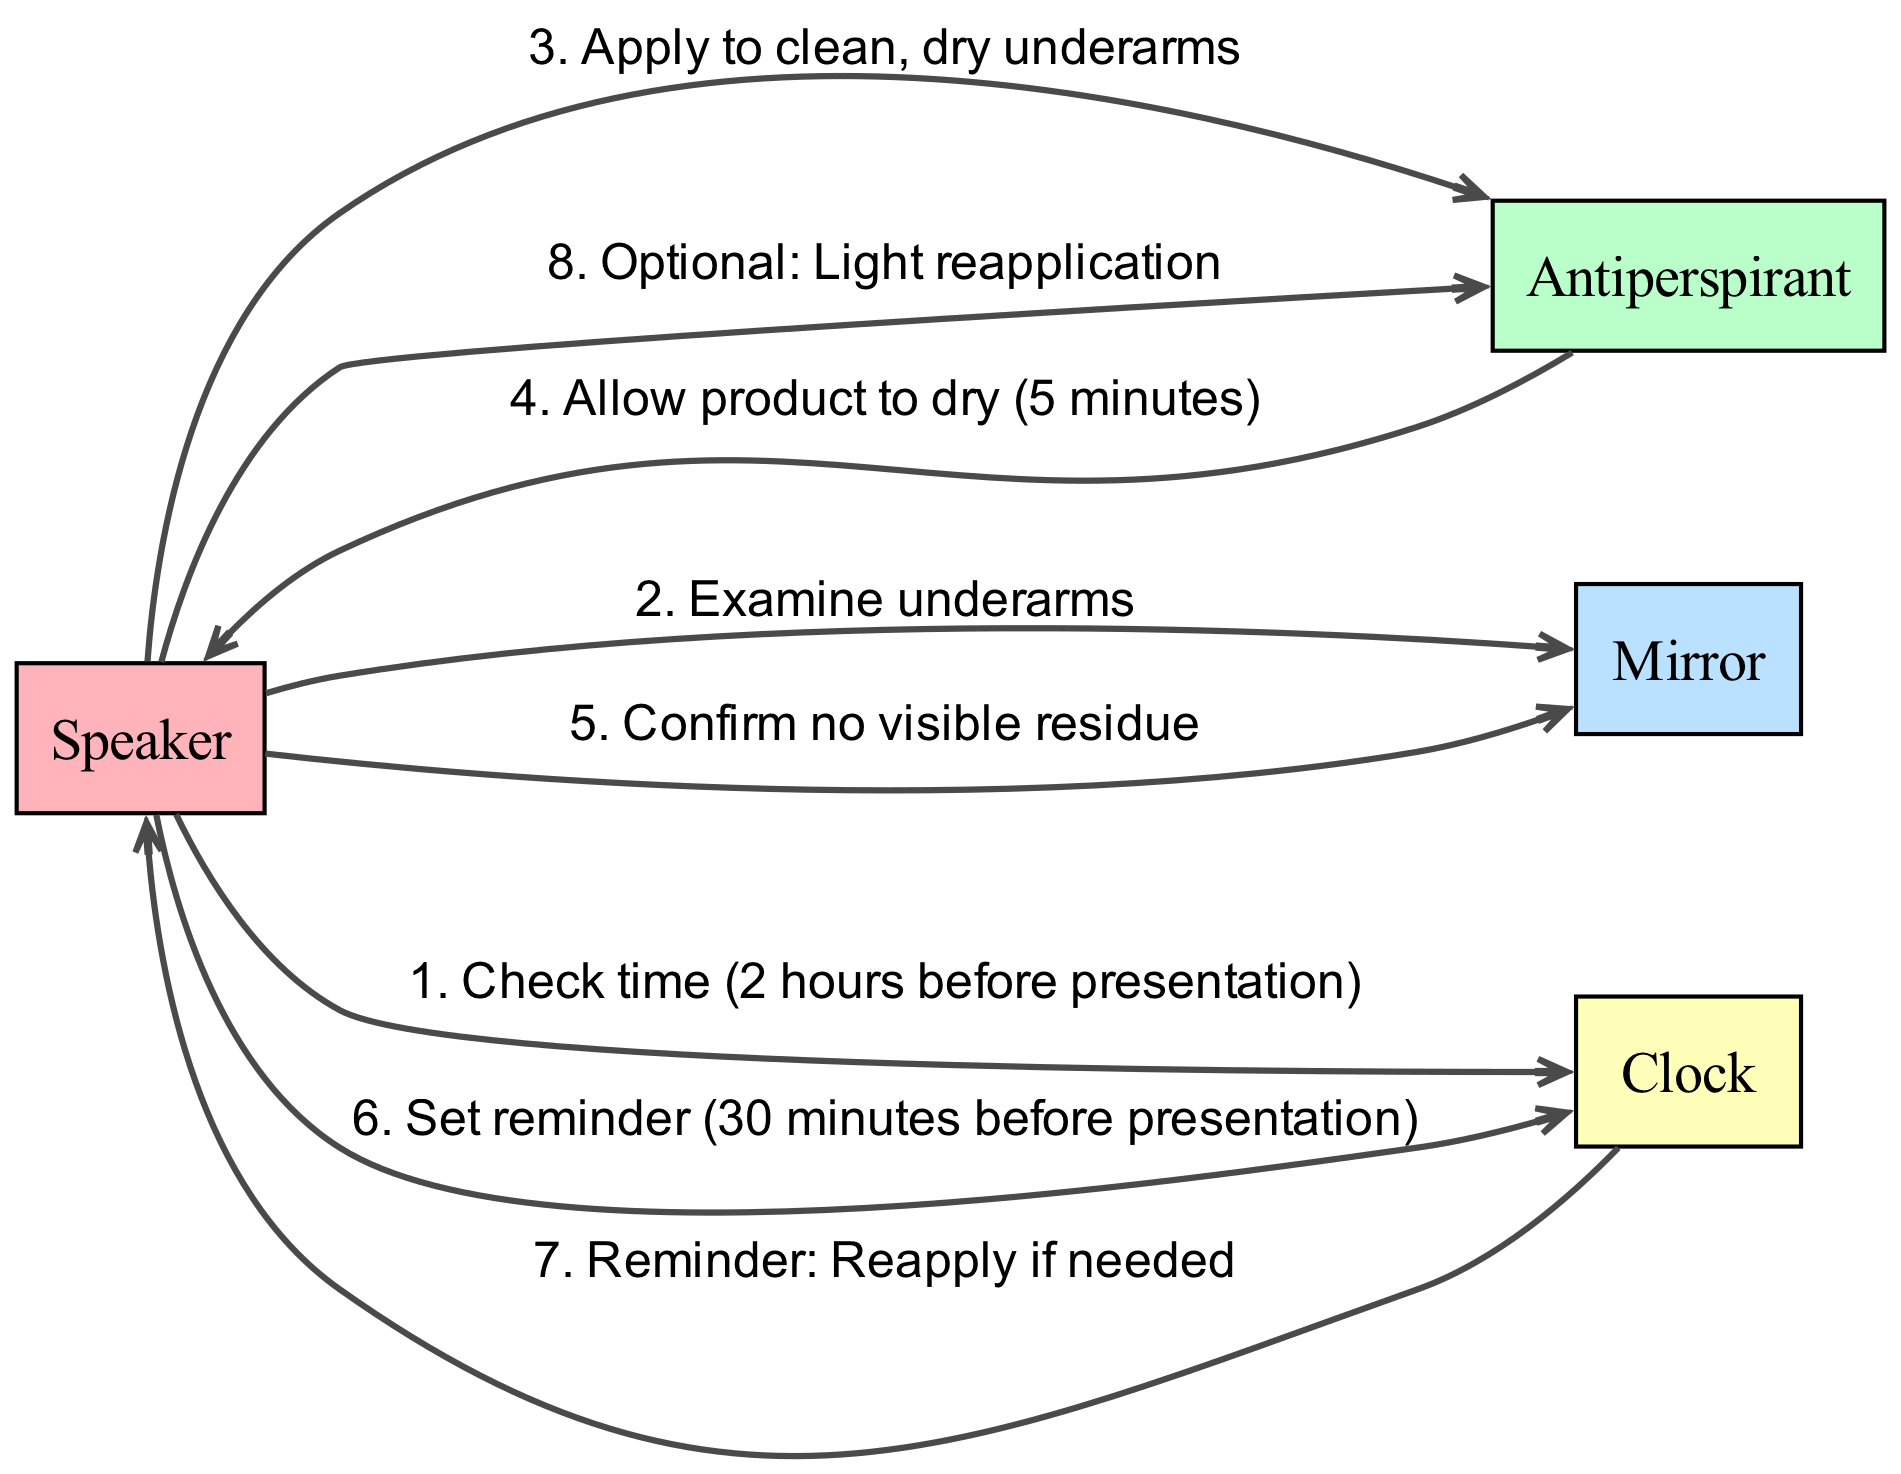What is the first action taken by the Speaker? The first action taken by the Speaker is checking the time before the presentation. This is represented as the first edge in the sequence from "Speaker" to "Clock", and is focused on the countdown prior to the presentation.
Answer: Check time (2 hours before presentation) How many minutes does the Antiperspirant require to dry? The drying time for the Antiperspirant is specified in the sequence as taking 5 minutes before the Speaker resumes preparation, which is noted in the fourth edge from "Antiperspirant" to "Speaker".
Answer: 5 minutes What is the last action related to the Antiperspirant? The last action in the sequence involving the Antiperspirant is the optional light reapplication by the Speaker. This is noted as the last step in the flow of the diagram from "Speaker" back to "Antiperspirant".
Answer: Optional: Light reapplication How many total steps are involved in the sequence? The total number of steps can be counted by evaluating each interaction in the sequence. There are eight distinct messages exchanged between the actors, making up the entirety of the process outlined in the diagram.
Answer: 8 What reminder does the Clock give to the Speaker? The Clock provides a reminder to the Speaker about the need for a reapplication if necessary, as noted in the sequence from "Clock" to "Speaker". This emphasizes the time-management aspect before the presentation.
Answer: Reminder: Reapply if needed What does the Speaker do after applying the Antiperspirant? After applying the Antiperspirant, the Speaker checks the mirror to confirm the absence of visible residue. This action follows directly after the product's application in the sequence.
Answer: Confirm no visible residue Which actor is involved in allowing the product to dry? The actor responsible for allowing the product to dry is the Antiperspirant itself. This is confirmed by the message from "Antiperspirant" back to "Speaker", indicating the drying time.
Answer: Antiperspirant What time does the Speaker set the reminder for? The Speaker sets a reminder for 30 minutes before the presentation. This action is represented as the fifth message from "Speaker" to "Clock" in the sequence of events.
Answer: 30 minutes before presentation 